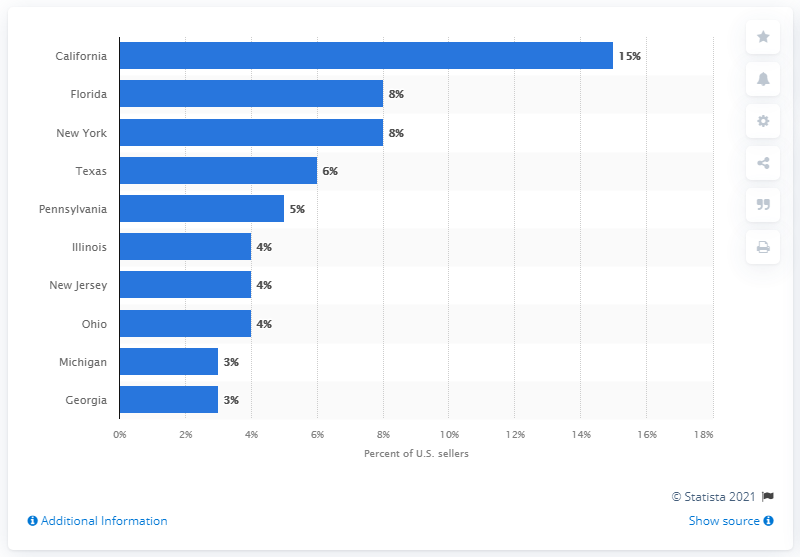Specify some key components in this picture. According to the data, the state with the largest share of eBay sellers was California. 